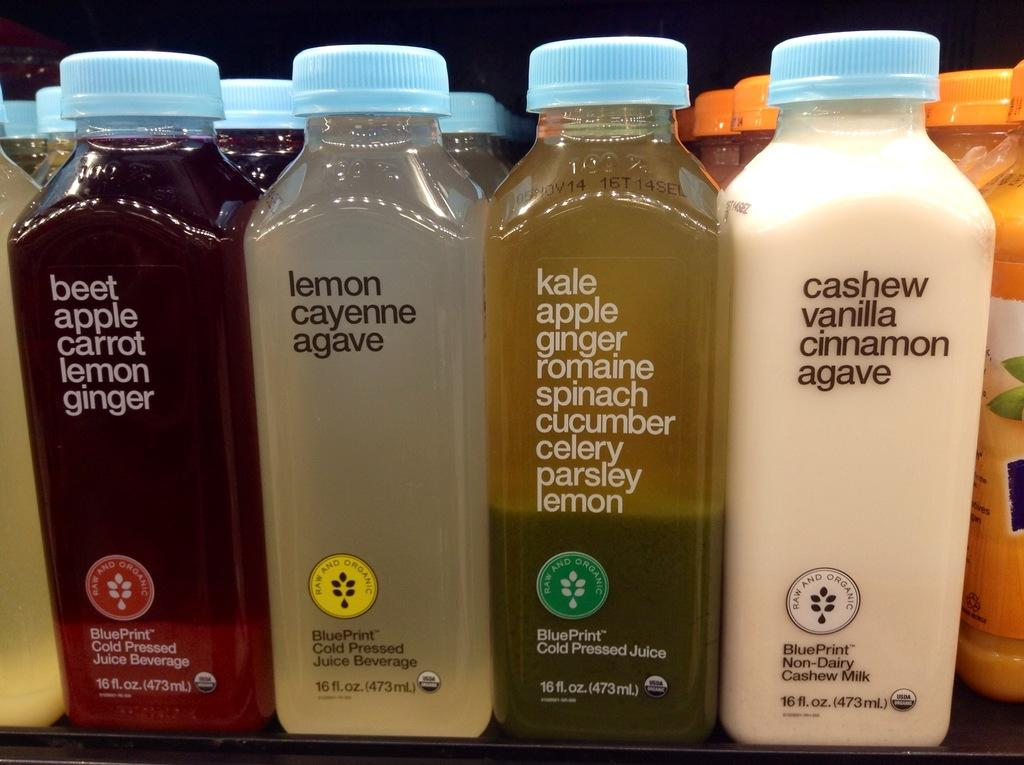<image>
Render a clear and concise summary of the photo. Several kinds of milk and juice are available for sale. 